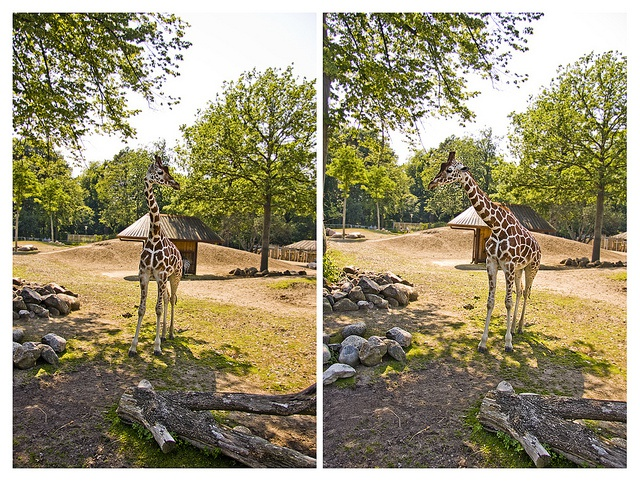Describe the objects in this image and their specific colors. I can see giraffe in white, maroon, tan, olive, and black tones and giraffe in white, black, olive, tan, and gray tones in this image. 